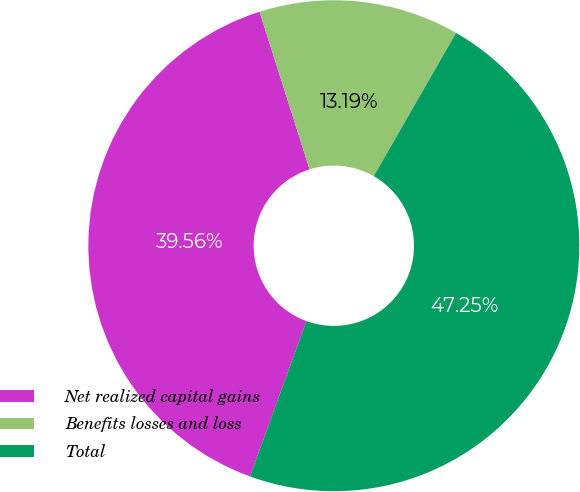Convert chart to OTSL. <chart><loc_0><loc_0><loc_500><loc_500><pie_chart><fcel>Net realized capital gains<fcel>Benefits losses and loss<fcel>Total<nl><fcel>39.56%<fcel>13.19%<fcel>47.25%<nl></chart> 